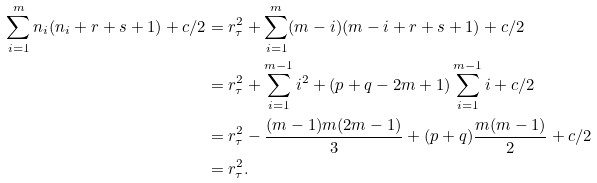<formula> <loc_0><loc_0><loc_500><loc_500>\sum _ { i = 1 } ^ { m } n _ { i } ( n _ { i } + r + s + 1 ) + c / 2 & = r _ { \tau } ^ { 2 } + \sum _ { i = 1 } ^ { m } ( m - i ) ( m - i + r + s + 1 ) + c / 2 \\ & = r _ { \tau } ^ { 2 } + \sum _ { i = 1 } ^ { m - 1 } i ^ { 2 } + ( p + q - 2 m + 1 ) \sum _ { i = 1 } ^ { m - 1 } i + c / 2 \\ & = r _ { \tau } ^ { 2 } - \frac { ( m - 1 ) m ( 2 m - 1 ) } { 3 } + ( p + q ) \frac { m ( m - 1 ) } { 2 } + c / 2 \\ & = r _ { \tau } ^ { 2 } .</formula> 